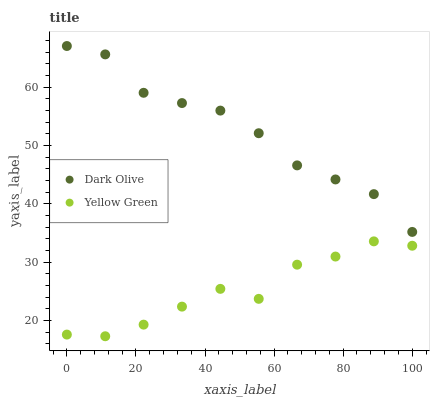Does Yellow Green have the minimum area under the curve?
Answer yes or no. Yes. Does Dark Olive have the maximum area under the curve?
Answer yes or no. Yes. Does Yellow Green have the maximum area under the curve?
Answer yes or no. No. Is Dark Olive the smoothest?
Answer yes or no. Yes. Is Yellow Green the roughest?
Answer yes or no. Yes. Is Yellow Green the smoothest?
Answer yes or no. No. Does Yellow Green have the lowest value?
Answer yes or no. Yes. Does Dark Olive have the highest value?
Answer yes or no. Yes. Does Yellow Green have the highest value?
Answer yes or no. No. Is Yellow Green less than Dark Olive?
Answer yes or no. Yes. Is Dark Olive greater than Yellow Green?
Answer yes or no. Yes. Does Yellow Green intersect Dark Olive?
Answer yes or no. No. 